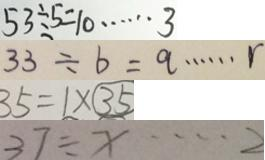Convert formula to latex. <formula><loc_0><loc_0><loc_500><loc_500>5 3 \div 5 = 1 0 \cdots 3 
 3 3 \div b = q \cdots r 
 3 5 = 1 \times \textcircled { 3 5 } 
 3 7 \div x \cdots 2</formula> 